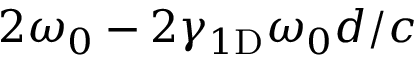<formula> <loc_0><loc_0><loc_500><loc_500>2 \omega _ { 0 } - 2 \gamma _ { 1 D } \omega _ { 0 } d / c</formula> 